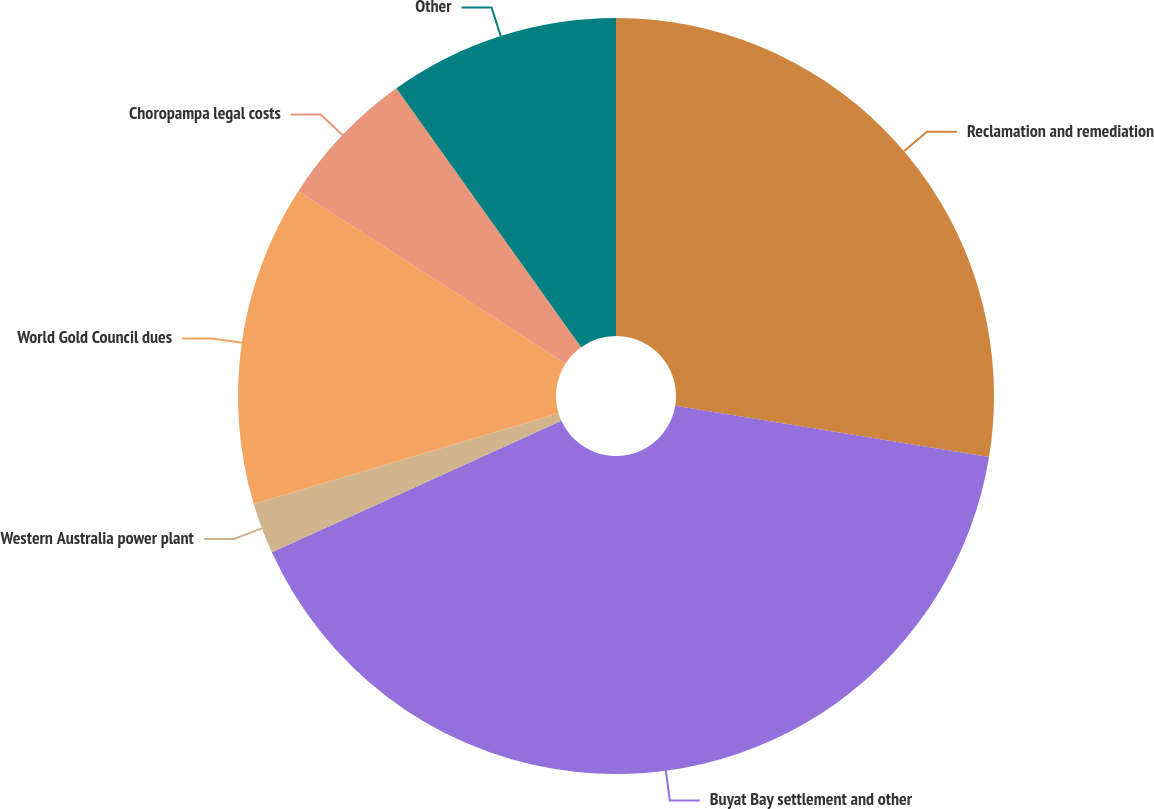Convert chart. <chart><loc_0><loc_0><loc_500><loc_500><pie_chart><fcel>Reclamation and remediation<fcel>Buyat Bay settlement and other<fcel>Western Australia power plant<fcel>World Gold Council dues<fcel>Choropampa legal costs<fcel>Other<nl><fcel>27.58%<fcel>40.64%<fcel>2.18%<fcel>13.72%<fcel>6.02%<fcel>9.87%<nl></chart> 